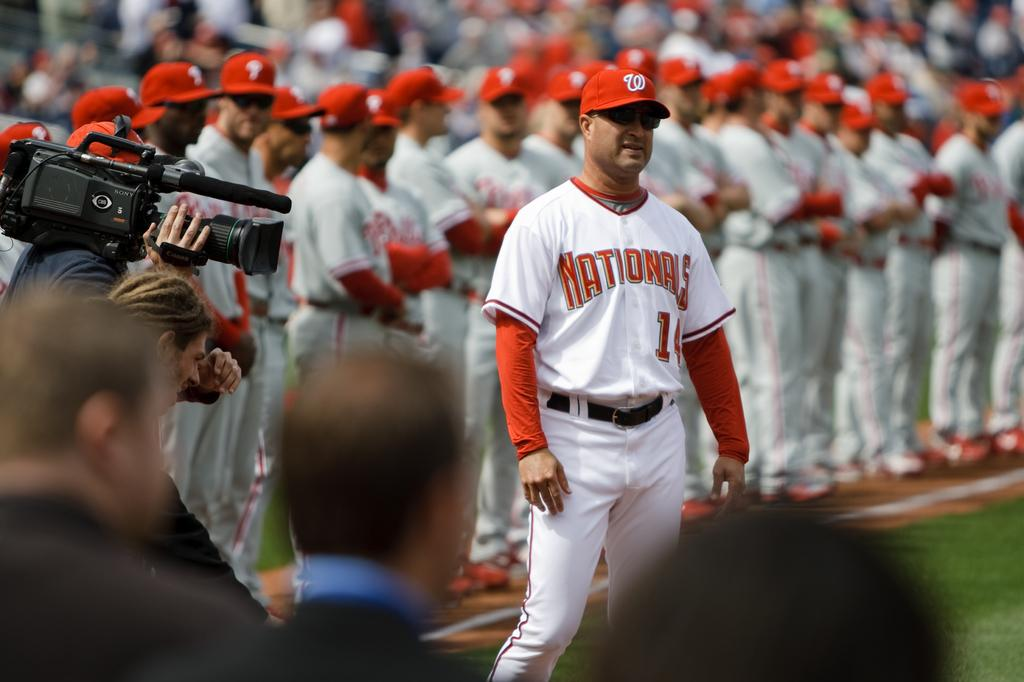<image>
Relay a brief, clear account of the picture shown. A bunch of people in Nationals uniforms stand together. 